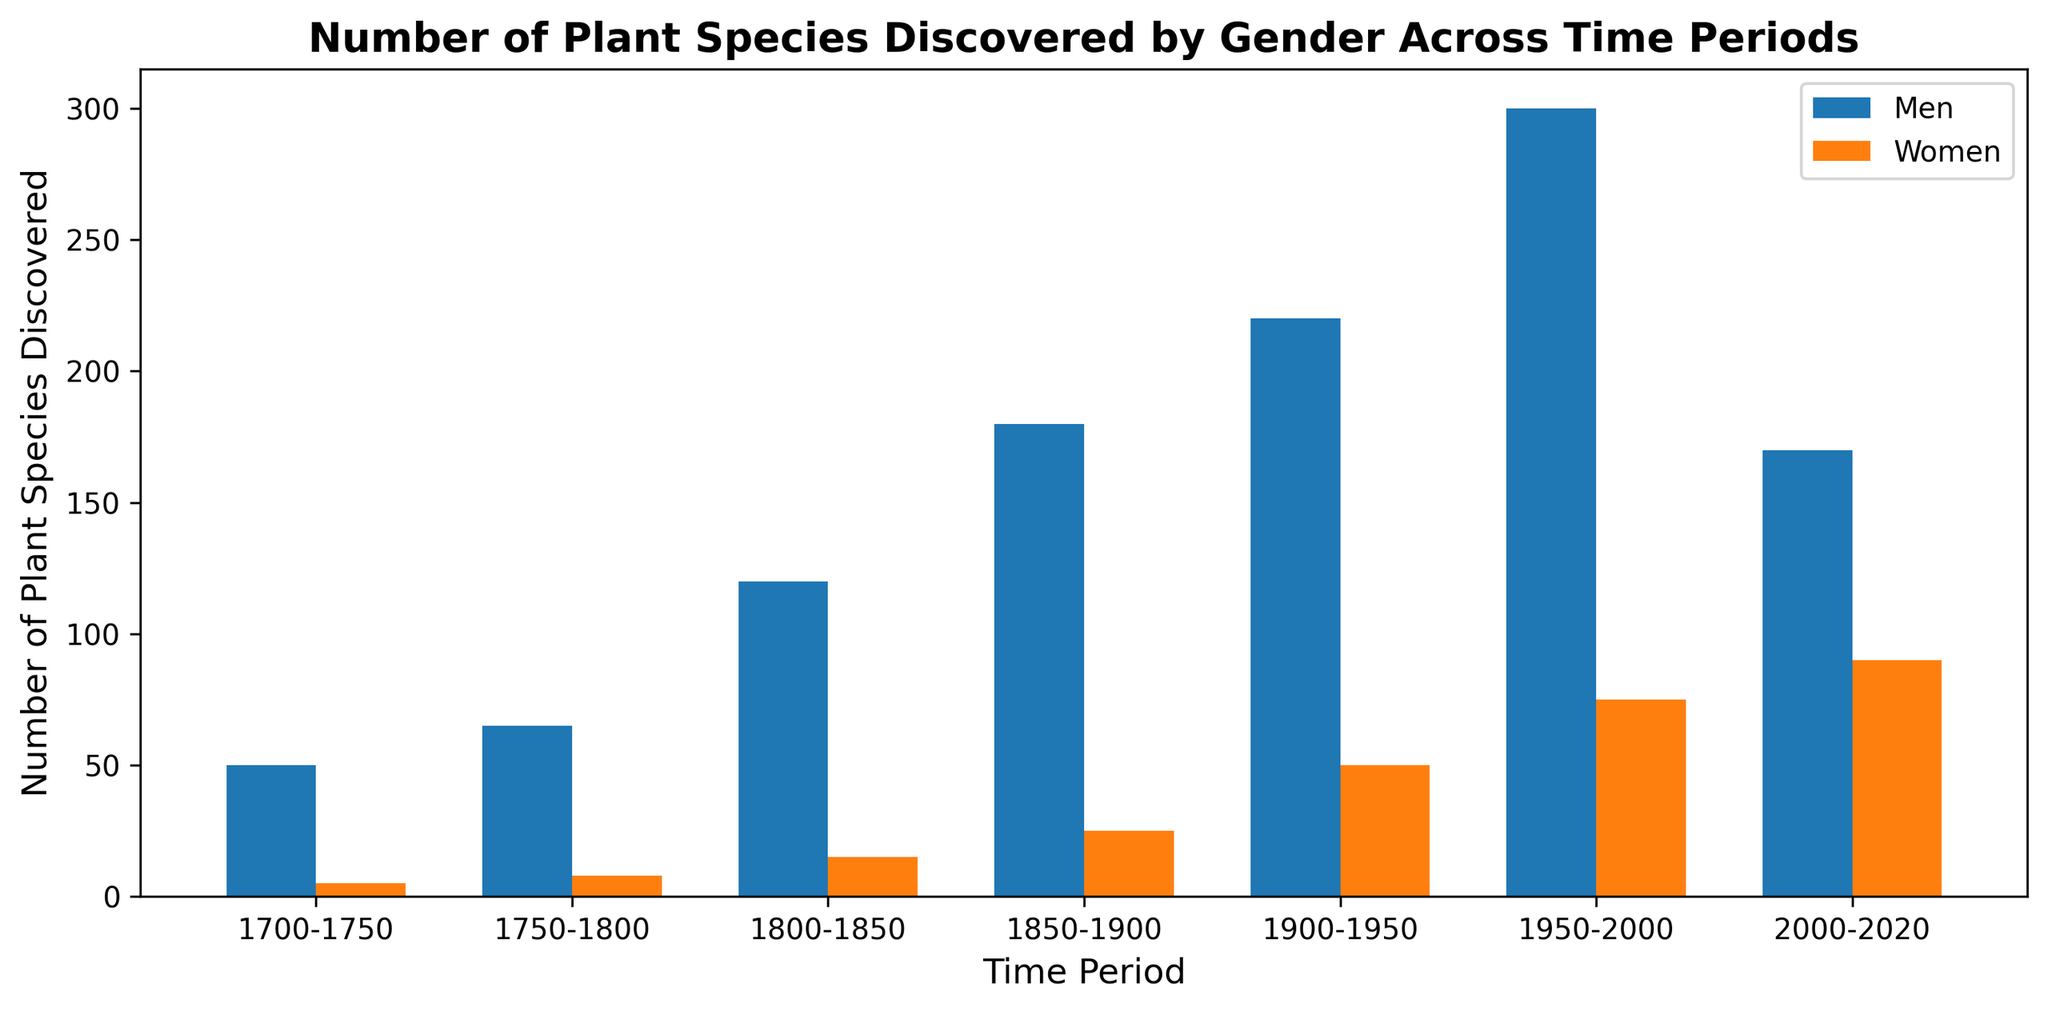Which gender discovered more plant species in the 2000-2020 period? By examining the height of the bars in the grouped bar plot, the bar representing women in 2000-2020 is taller than the bar representing men. Hence, women discovered more plant species in this period.
Answer: Women How many more plant species were discovered by men than by women in the 1950-2000 period? Men: 300 plant species, Women: 75 plant species. The difference is 300 - 75 = 225.
Answer: 225 What is the total number of plant species discovered by women from 1700-2000? Summing the number of species discovered by women across relevant periods: 5 + 8 + 15 + 25 + 50 + 75 = 178
Answer: 178 In which time period was the total number of plant species discoveries by both genders the highest? Comparing the total number of discoveries by summing both genders' numbers for each period, the highest total is in the period 1950-2000: 300 (men) + 75 (women) = 375.
Answer: 1950-2000 How does the number of plant species discovered by women in 1850-1900 compare to that in 1900-1950? Comparing the heights of the bars, in 1900-1950 (50) it is higher than in 1850-1900 (25).
Answer: 1900-1950 is higher What is the average number of plant species discovered by men across all time periods? Adding the discoveries by men: 50 + 65 + 120 + 180 + 220 + 300 + 170 = 1105. There are 7 time periods, so the average is 1105 / 7 ≈ 158.
Answer: 158 In which time period did women discover the fewest plant species? The shortest bar representing women’s discoveries is for the 1700-1750 period, with 5 species discovered.
Answer: 1700-1750 What percentage of the total plant species discovered by both genders in 2000-2020 were discovered by women? Men: 170, Women: 90. Total: 170 + 90 = 260. Percentage: (90 / 260) * 100 ≈ 34.6%.
Answer: 34.6% Which gender showed a more significant increase in the number of plant species discovered from 1800-1850 to 1850-1900? Men: 180 - 120 = 60. Women: 25 - 15 = 10. The increase for men (60) is greater than that for women (10).
Answer: Men 